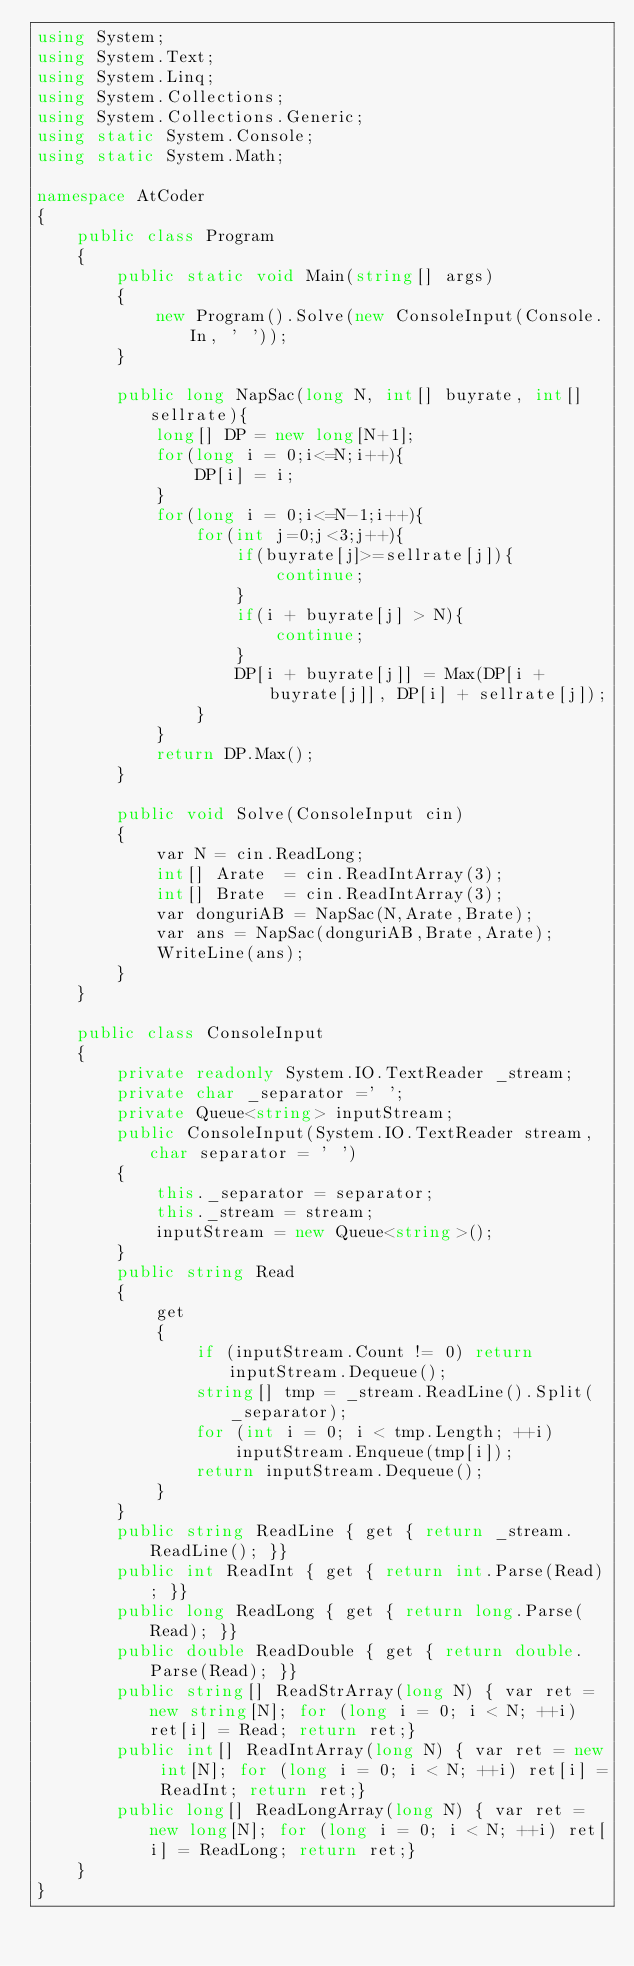<code> <loc_0><loc_0><loc_500><loc_500><_C#_>using System;
using System.Text;
using System.Linq;
using System.Collections;
using System.Collections.Generic;
using static System.Console;
using static System.Math;

namespace AtCoder
{
    public class Program
    {
        public static void Main(string[] args)
        {
            new Program().Solve(new ConsoleInput(Console.In, ' '));
        }

        public long NapSac(long N, int[] buyrate, int[] sellrate){
            long[] DP = new long[N+1];
            for(long i = 0;i<=N;i++){
                DP[i] = i;
            }
            for(long i = 0;i<=N-1;i++){
                for(int j=0;j<3;j++){
                    if(buyrate[j]>=sellrate[j]){
                        continue;
                    }
                    if(i + buyrate[j] > N){
                        continue;
                    }
                    DP[i + buyrate[j]] = Max(DP[i + buyrate[j]], DP[i] + sellrate[j]);
                }
            }
            return DP.Max();
        }

        public void Solve(ConsoleInput cin)
        {
            var N = cin.ReadLong;
            int[] Arate  = cin.ReadIntArray(3);
            int[] Brate  = cin.ReadIntArray(3);
            var donguriAB = NapSac(N,Arate,Brate);
            var ans = NapSac(donguriAB,Brate,Arate);
            WriteLine(ans);
        }
    }

    public class ConsoleInput
    {
        private readonly System.IO.TextReader _stream;
        private char _separator =' ';
        private Queue<string> inputStream;
        public ConsoleInput(System.IO.TextReader stream, char separator = ' ')
        {
            this._separator = separator;
            this._stream = stream;
            inputStream = new Queue<string>();
        }
        public string Read
        {
            get
            {
                if (inputStream.Count != 0) return inputStream.Dequeue();
                string[] tmp = _stream.ReadLine().Split(_separator);
                for (int i = 0; i < tmp.Length; ++i)
                    inputStream.Enqueue(tmp[i]);
                return inputStream.Dequeue();
            }
        }
        public string ReadLine { get { return _stream.ReadLine(); }}
        public int ReadInt { get { return int.Parse(Read); }}
        public long ReadLong { get { return long.Parse(Read); }}
        public double ReadDouble { get { return double.Parse(Read); }}
        public string[] ReadStrArray(long N) { var ret = new string[N]; for (long i = 0; i < N; ++i) ret[i] = Read; return ret;}
        public int[] ReadIntArray(long N) { var ret = new int[N]; for (long i = 0; i < N; ++i) ret[i] = ReadInt; return ret;}
        public long[] ReadLongArray(long N) { var ret = new long[N]; for (long i = 0; i < N; ++i) ret[i] = ReadLong; return ret;}
    }
}
</code> 